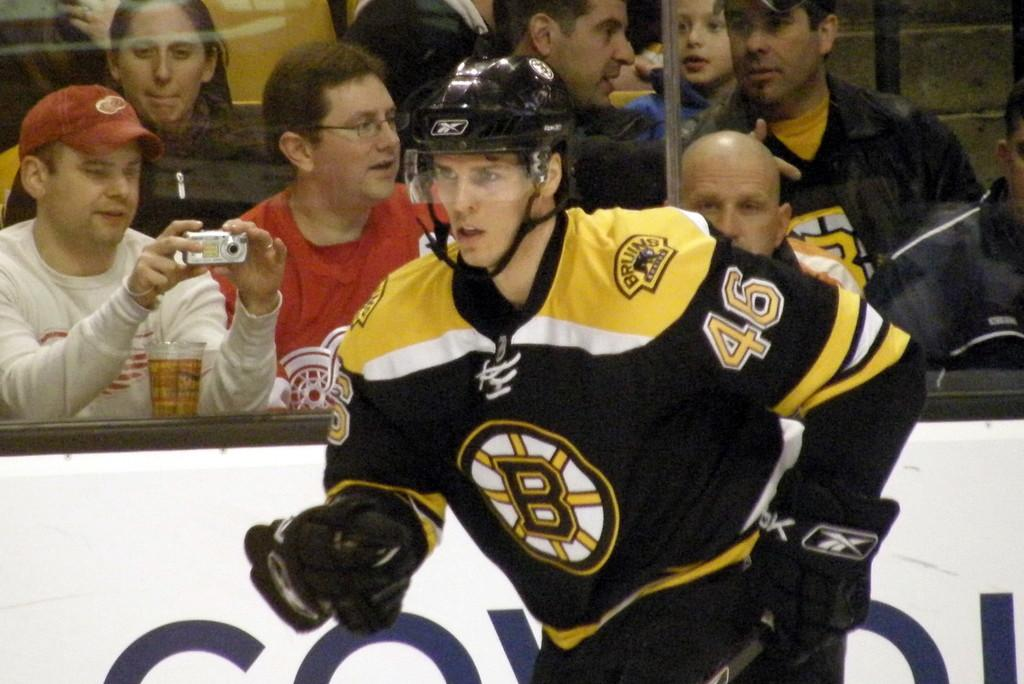Provide a one-sentence caption for the provided image. A Bruins hockey player rushes along the barrier of the rink. 